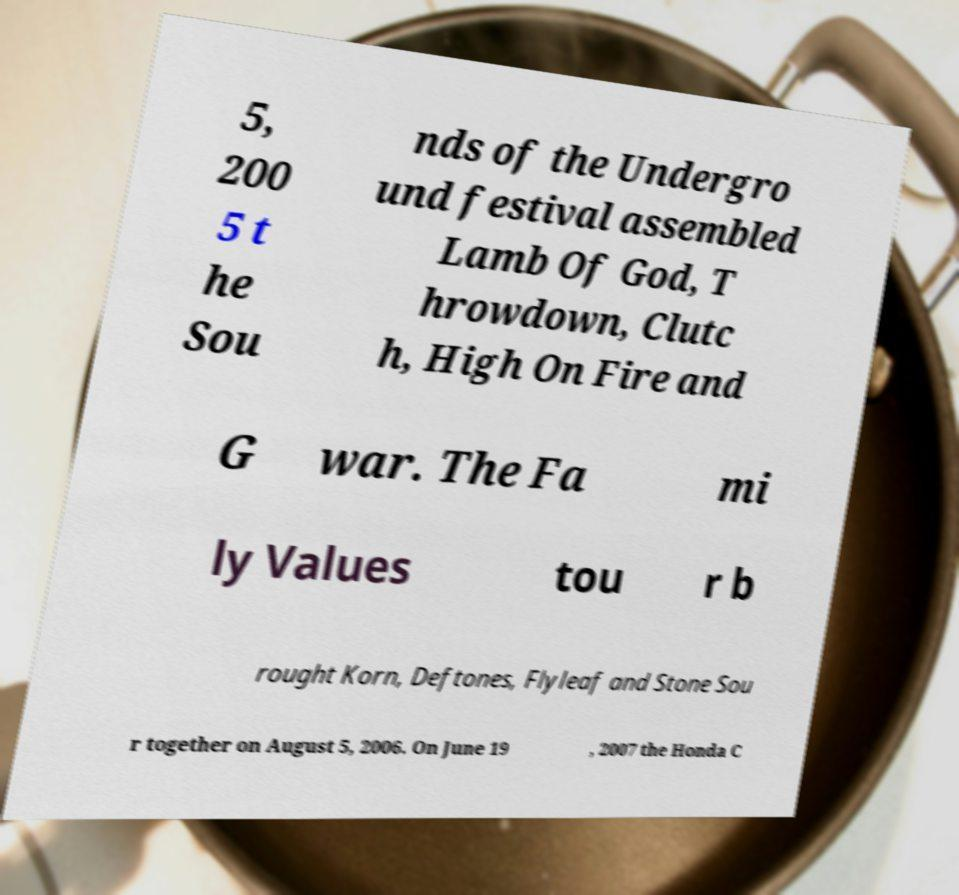What messages or text are displayed in this image? I need them in a readable, typed format. 5, 200 5 t he Sou nds of the Undergro und festival assembled Lamb Of God, T hrowdown, Clutc h, High On Fire and G war. The Fa mi ly Values tou r b rought Korn, Deftones, Flyleaf and Stone Sou r together on August 5, 2006. On June 19 , 2007 the Honda C 